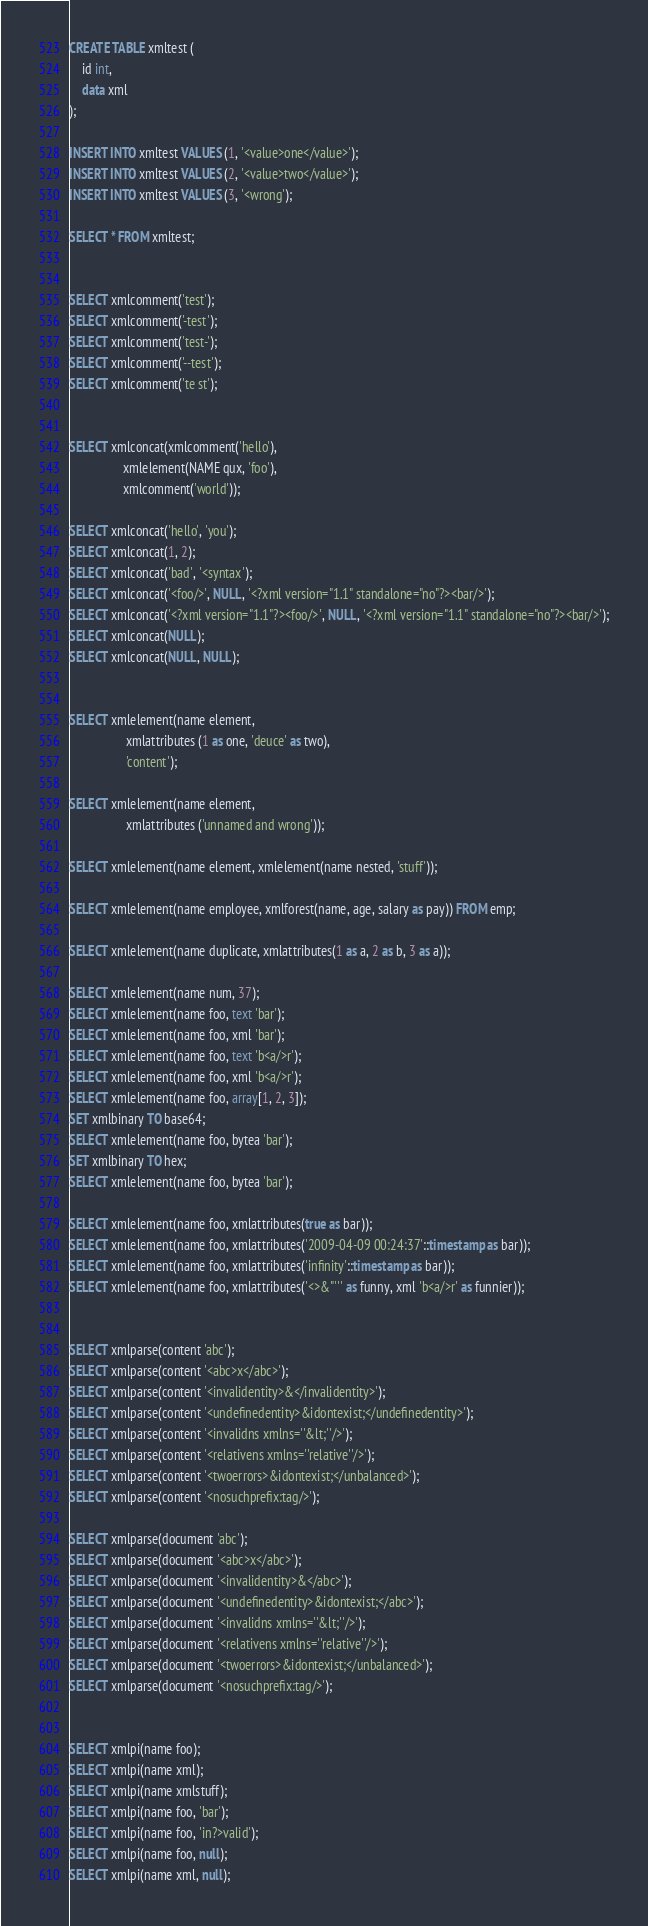<code> <loc_0><loc_0><loc_500><loc_500><_SQL_>CREATE TABLE xmltest (
    id int,
    data xml
);

INSERT INTO xmltest VALUES (1, '<value>one</value>');
INSERT INTO xmltest VALUES (2, '<value>two</value>');
INSERT INTO xmltest VALUES (3, '<wrong');

SELECT * FROM xmltest;


SELECT xmlcomment('test');
SELECT xmlcomment('-test');
SELECT xmlcomment('test-');
SELECT xmlcomment('--test');
SELECT xmlcomment('te st');


SELECT xmlconcat(xmlcomment('hello'),
                 xmlelement(NAME qux, 'foo'),
                 xmlcomment('world'));

SELECT xmlconcat('hello', 'you');
SELECT xmlconcat(1, 2);
SELECT xmlconcat('bad', '<syntax');
SELECT xmlconcat('<foo/>', NULL, '<?xml version="1.1" standalone="no"?><bar/>');
SELECT xmlconcat('<?xml version="1.1"?><foo/>', NULL, '<?xml version="1.1" standalone="no"?><bar/>');
SELECT xmlconcat(NULL);
SELECT xmlconcat(NULL, NULL);


SELECT xmlelement(name element,
                  xmlattributes (1 as one, 'deuce' as two),
                  'content');

SELECT xmlelement(name element,
                  xmlattributes ('unnamed and wrong'));

SELECT xmlelement(name element, xmlelement(name nested, 'stuff'));

SELECT xmlelement(name employee, xmlforest(name, age, salary as pay)) FROM emp;

SELECT xmlelement(name duplicate, xmlattributes(1 as a, 2 as b, 3 as a));

SELECT xmlelement(name num, 37);
SELECT xmlelement(name foo, text 'bar');
SELECT xmlelement(name foo, xml 'bar');
SELECT xmlelement(name foo, text 'b<a/>r');
SELECT xmlelement(name foo, xml 'b<a/>r');
SELECT xmlelement(name foo, array[1, 2, 3]);
SET xmlbinary TO base64;
SELECT xmlelement(name foo, bytea 'bar');
SET xmlbinary TO hex;
SELECT xmlelement(name foo, bytea 'bar');

SELECT xmlelement(name foo, xmlattributes(true as bar));
SELECT xmlelement(name foo, xmlattributes('2009-04-09 00:24:37'::timestamp as bar));
SELECT xmlelement(name foo, xmlattributes('infinity'::timestamp as bar));
SELECT xmlelement(name foo, xmlattributes('<>&"''' as funny, xml 'b<a/>r' as funnier));


SELECT xmlparse(content 'abc');
SELECT xmlparse(content '<abc>x</abc>');
SELECT xmlparse(content '<invalidentity>&</invalidentity>');
SELECT xmlparse(content '<undefinedentity>&idontexist;</undefinedentity>');
SELECT xmlparse(content '<invalidns xmlns=''&lt;''/>');
SELECT xmlparse(content '<relativens xmlns=''relative''/>');
SELECT xmlparse(content '<twoerrors>&idontexist;</unbalanced>');
SELECT xmlparse(content '<nosuchprefix:tag/>');

SELECT xmlparse(document 'abc');
SELECT xmlparse(document '<abc>x</abc>');
SELECT xmlparse(document '<invalidentity>&</abc>');
SELECT xmlparse(document '<undefinedentity>&idontexist;</abc>');
SELECT xmlparse(document '<invalidns xmlns=''&lt;''/>');
SELECT xmlparse(document '<relativens xmlns=''relative''/>');
SELECT xmlparse(document '<twoerrors>&idontexist;</unbalanced>');
SELECT xmlparse(document '<nosuchprefix:tag/>');


SELECT xmlpi(name foo);
SELECT xmlpi(name xml);
SELECT xmlpi(name xmlstuff);
SELECT xmlpi(name foo, 'bar');
SELECT xmlpi(name foo, 'in?>valid');
SELECT xmlpi(name foo, null);
SELECT xmlpi(name xml, null);</code> 